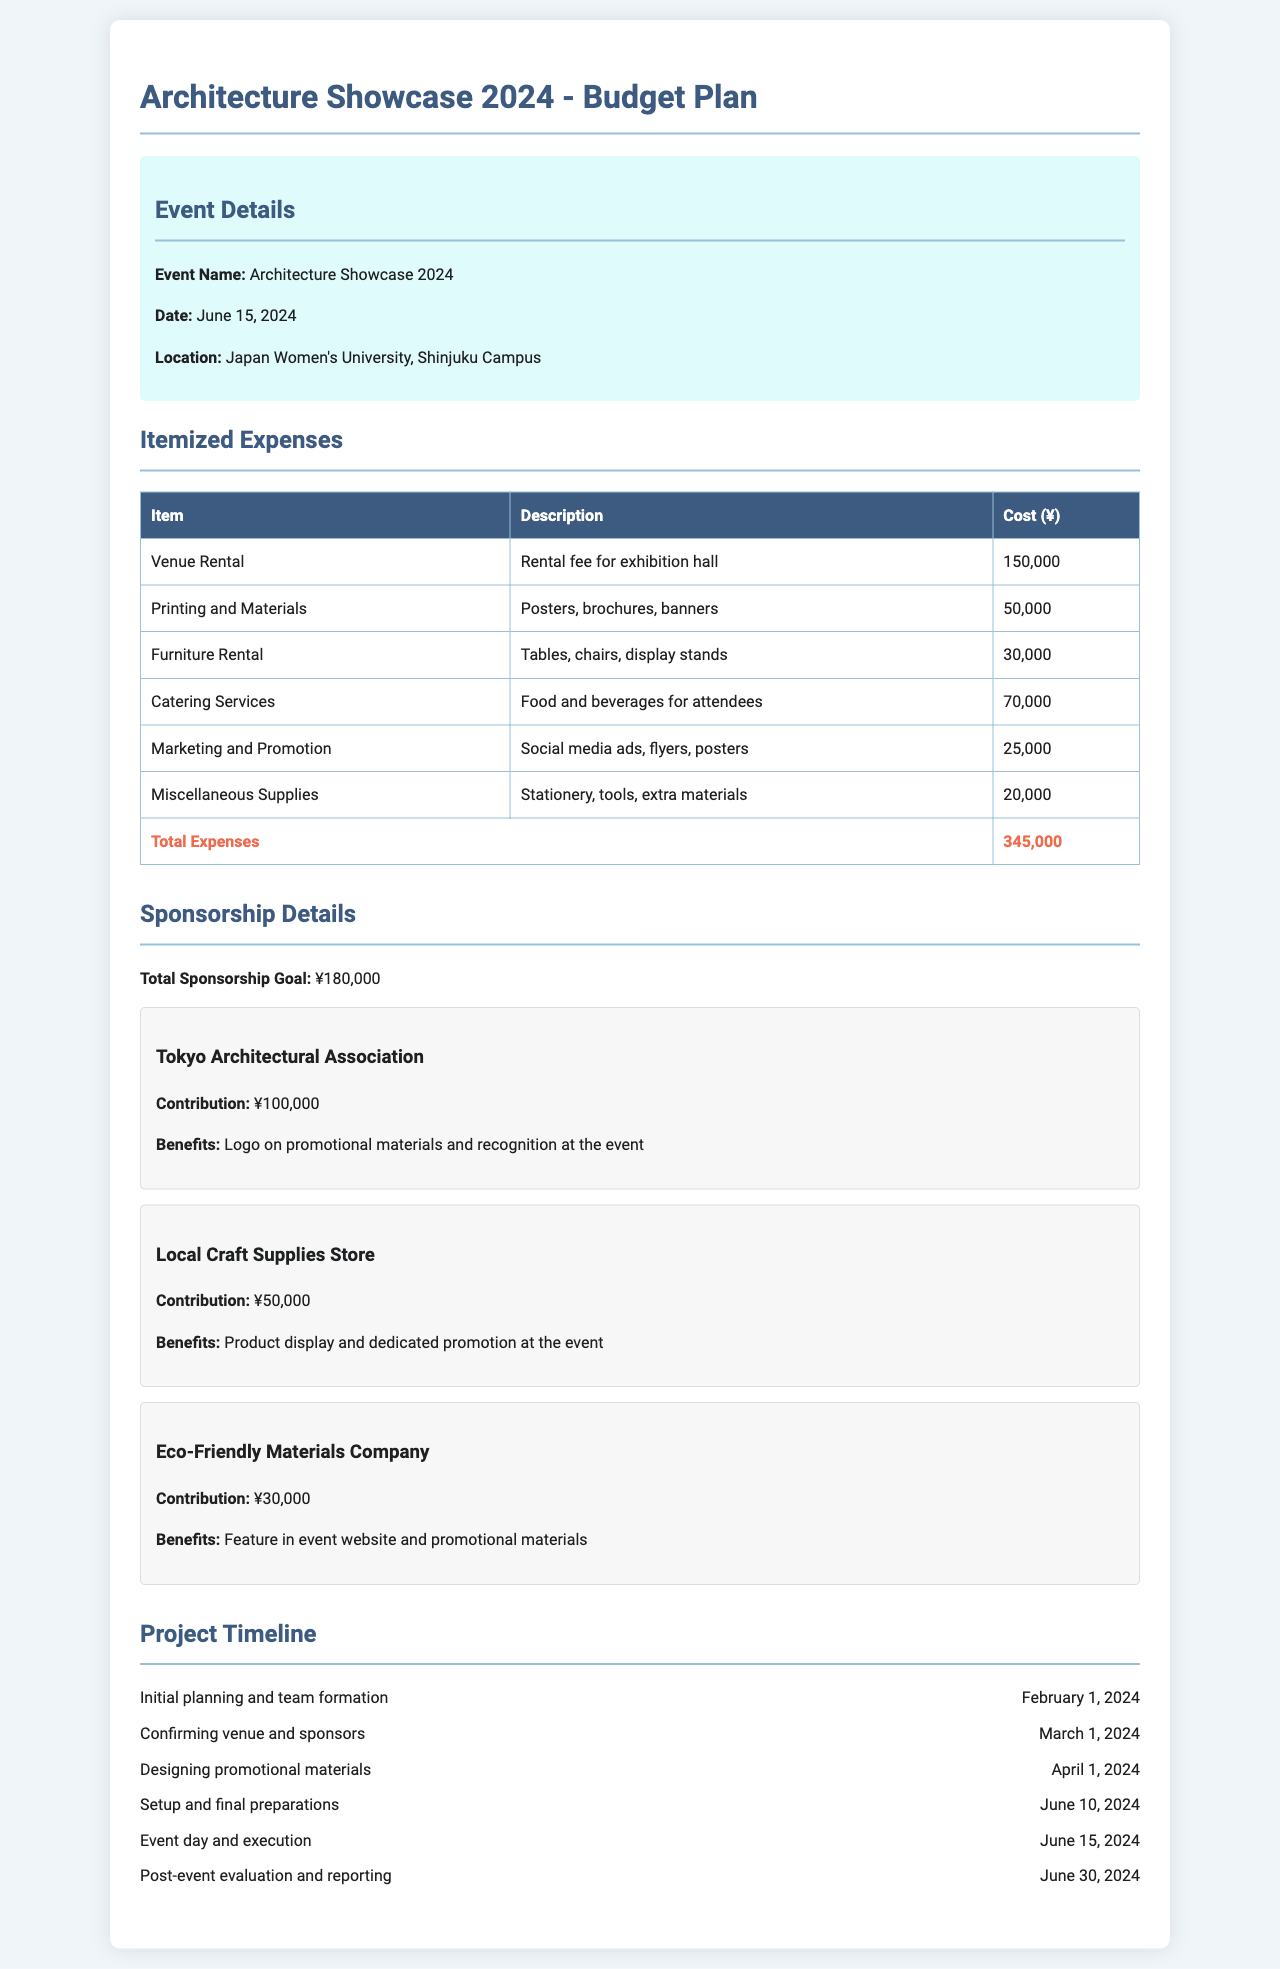what is the event name? The event name is mentioned at the beginning of the document under "Event Details."
Answer: Architecture Showcase 2024 what is the date of the event? The date of the event is provided in the "Event Details" section.
Answer: June 15, 2024 how much is allocated for catering services? The specific cost for catering services is listed in the "Itemized Expenses" table.
Answer: 70,000 who is the main sponsor and what is their contribution? The main sponsor and their contribution can be found in the "Sponsorship Details" section.
Answer: Tokyo Architectural Association, ¥100,000 what is the total amount for itemized expenses? The total for itemized expenses is calculated and noted in the "Itemized Expenses" table.
Answer: 345,000 when is the event day? The event day is mentioned directly under "Event Details."
Answer: June 15, 2024 what will happen on June 30, 2024? The timeline outlines what occurs on this date.
Answer: Post-event evaluation and reporting how much sponsorship is needed in total? The total sponsorship goal is specified in the "Sponsorship Details."
Answer: ¥180,000 what is the purpose of the miscellaneous supplies expense? The "Miscellaneous Supplies" entry describes the purpose in the "Itemized Expenses."
Answer: Stationery, tools, extra materials 